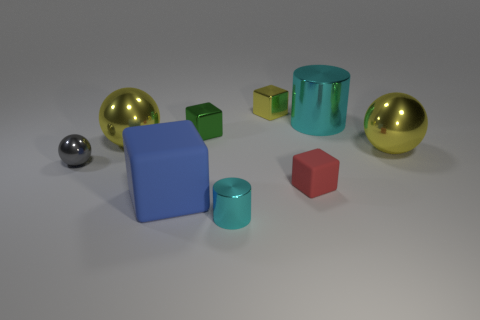What shape is the metallic object that is on the left side of the large block and behind the tiny gray metallic object?
Offer a very short reply. Sphere. Are there more large yellow spheres than tiny green shiny blocks?
Provide a succinct answer. Yes. What is the small yellow cube made of?
Provide a succinct answer. Metal. What size is the blue matte object that is the same shape as the red matte object?
Give a very brief answer. Large. Are there any small metal objects that are on the left side of the yellow shiny object that is to the left of the yellow metallic block?
Keep it short and to the point. Yes. Is the color of the big cylinder the same as the tiny cylinder?
Offer a terse response. Yes. How many other objects are there of the same shape as the small yellow metal thing?
Your answer should be compact. 3. Is the number of big things behind the tiny red thing greater than the number of big yellow metallic balls in front of the tiny cyan metallic thing?
Keep it short and to the point. Yes. Is the size of the yellow thing left of the blue matte block the same as the metallic cylinder behind the blue cube?
Offer a very short reply. Yes. The small red matte thing has what shape?
Your answer should be compact. Cube. 